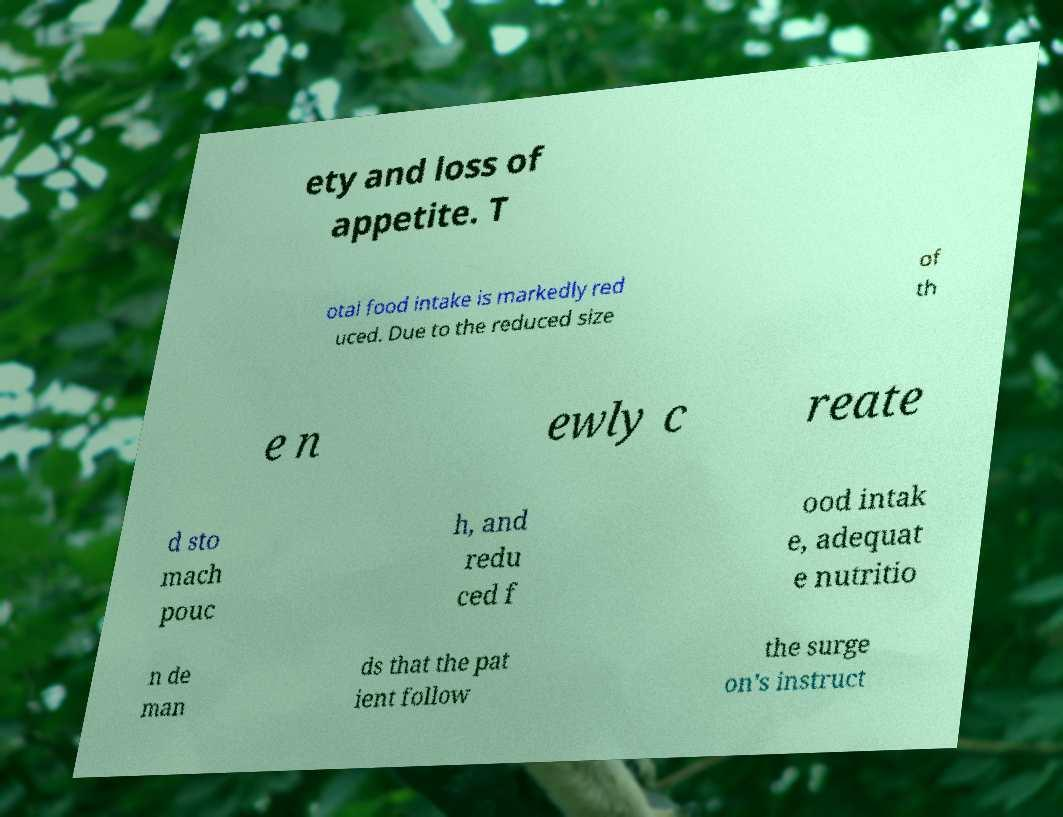Can you read and provide the text displayed in the image?This photo seems to have some interesting text. Can you extract and type it out for me? ety and loss of appetite. T otal food intake is markedly red uced. Due to the reduced size of th e n ewly c reate d sto mach pouc h, and redu ced f ood intak e, adequat e nutritio n de man ds that the pat ient follow the surge on's instruct 